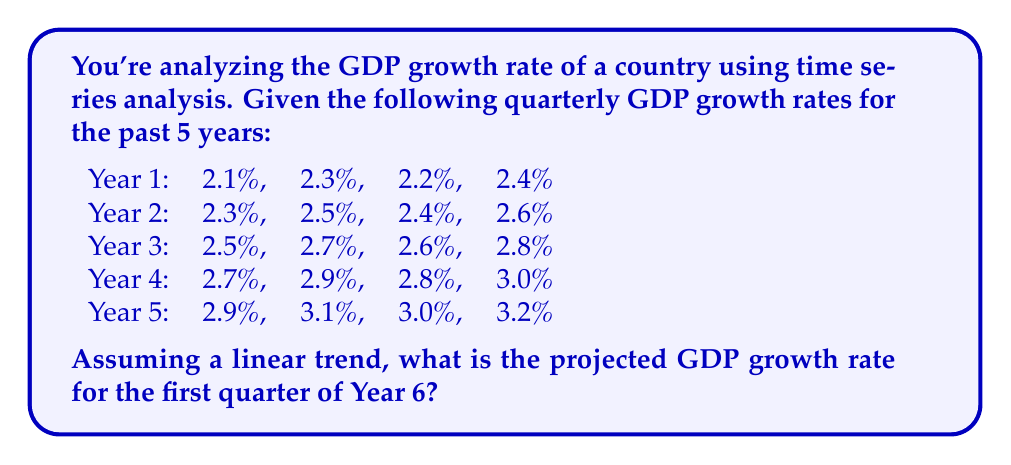Teach me how to tackle this problem. To forecast the GDP growth rate for the first quarter of Year 6 using time series analysis with a linear trend, we'll follow these steps:

1. Assign time values to each quarter, starting from 1 for the first quarter of Year 1 to 20 for the last quarter of Year 5.

2. Create a linear regression model:
   Let $y$ be the GDP growth rate and $x$ be the time period.
   The linear model is: $y = mx + b$

3. Calculate the means:
   $\bar{x} = \frac{1+2+...+20}{20} = 10.5$
   $\bar{y} = \frac{2.1+2.3+...+3.2}{20} = 2.65$

4. Calculate the slope $m$:
   $m = \frac{\sum(x_i - \bar{x})(y_i - \bar{y})}{\sum(x_i - \bar{x})^2}$

   Numerator: $\sum(x_i - \bar{x})(y_i - \bar{y}) = 19.8$
   Denominator: $\sum(x_i - \bar{x})^2 = 665$

   $m = \frac{19.8}{665} = 0.0298$

5. Calculate the y-intercept $b$:
   $b = \bar{y} - m\bar{x} = 2.65 - 0.0298(10.5) = 2.3371$

6. The linear regression equation is:
   $y = 0.0298x + 2.3371$

7. For the first quarter of Year 6, $x = 21$:
   $y = 0.0298(21) + 2.3371 = 3.0629$

Therefore, the projected GDP growth rate for the first quarter of Year 6 is approximately 3.06%.
Answer: 3.06% 